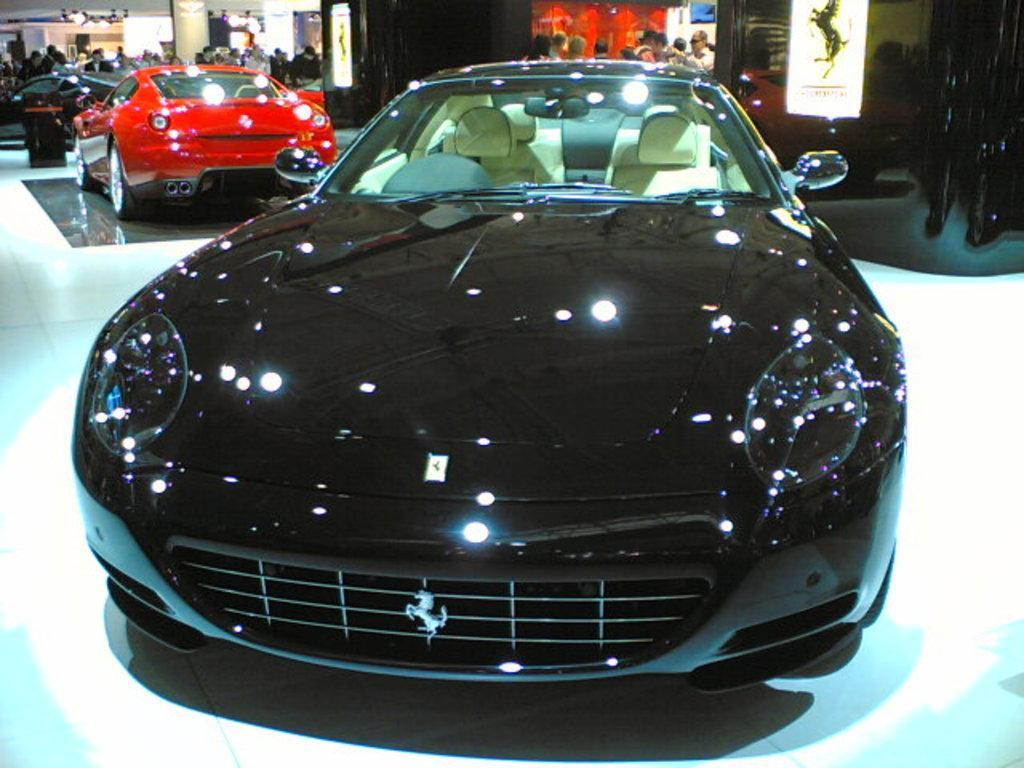Could you give a brief overview of what you see in this image? In this picture I can see cars on the floor. The car in the front is black in color. Here I can see a red color car. In the background I can see people are standing and some logos on the wall. 